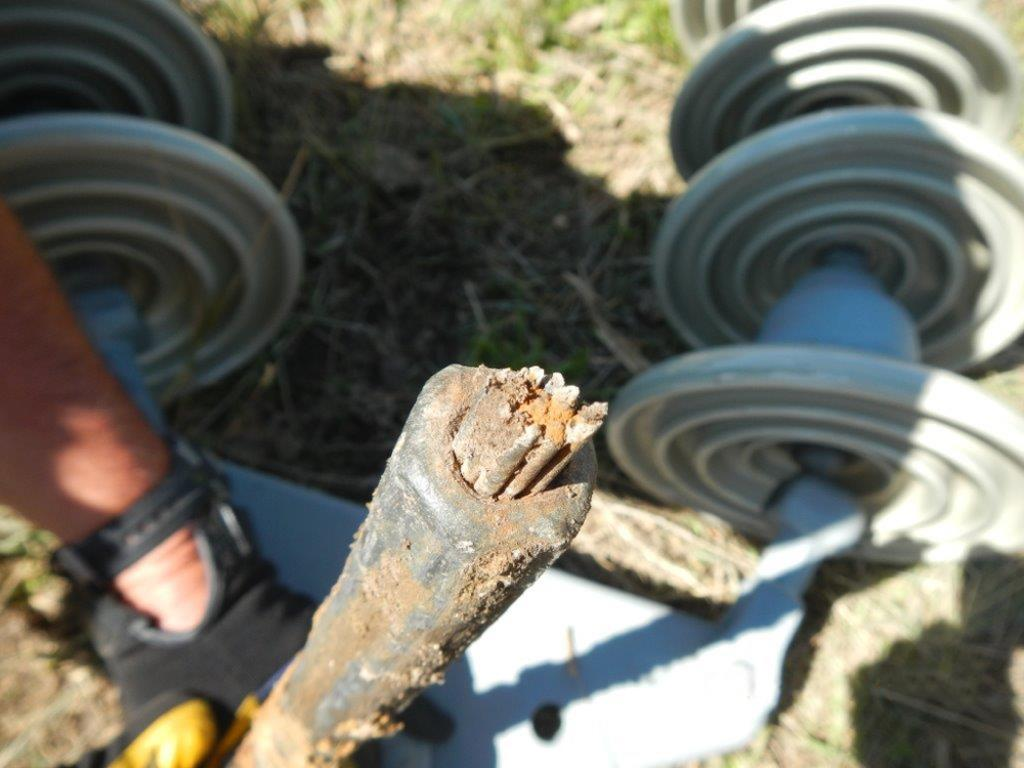What part of the human body is visible in the image? There is a human hand in the image. What is the hand wearing? The hand is wearing a glove. What can be seen in the background of the image? There is a pole and grass visible in the image. Can you describe the unspecified object in the image? Unfortunately, the facts provided do not give enough information to describe the unspecified object in the image. How does the hand aid in the digestion process in the image? The hand does not aid in the digestion process in the image; it is simply a hand wearing a glove. What type of bead is being used to create the pattern on the grass in the image? There is no bead present in the image, and the grass does not have a pattern. 